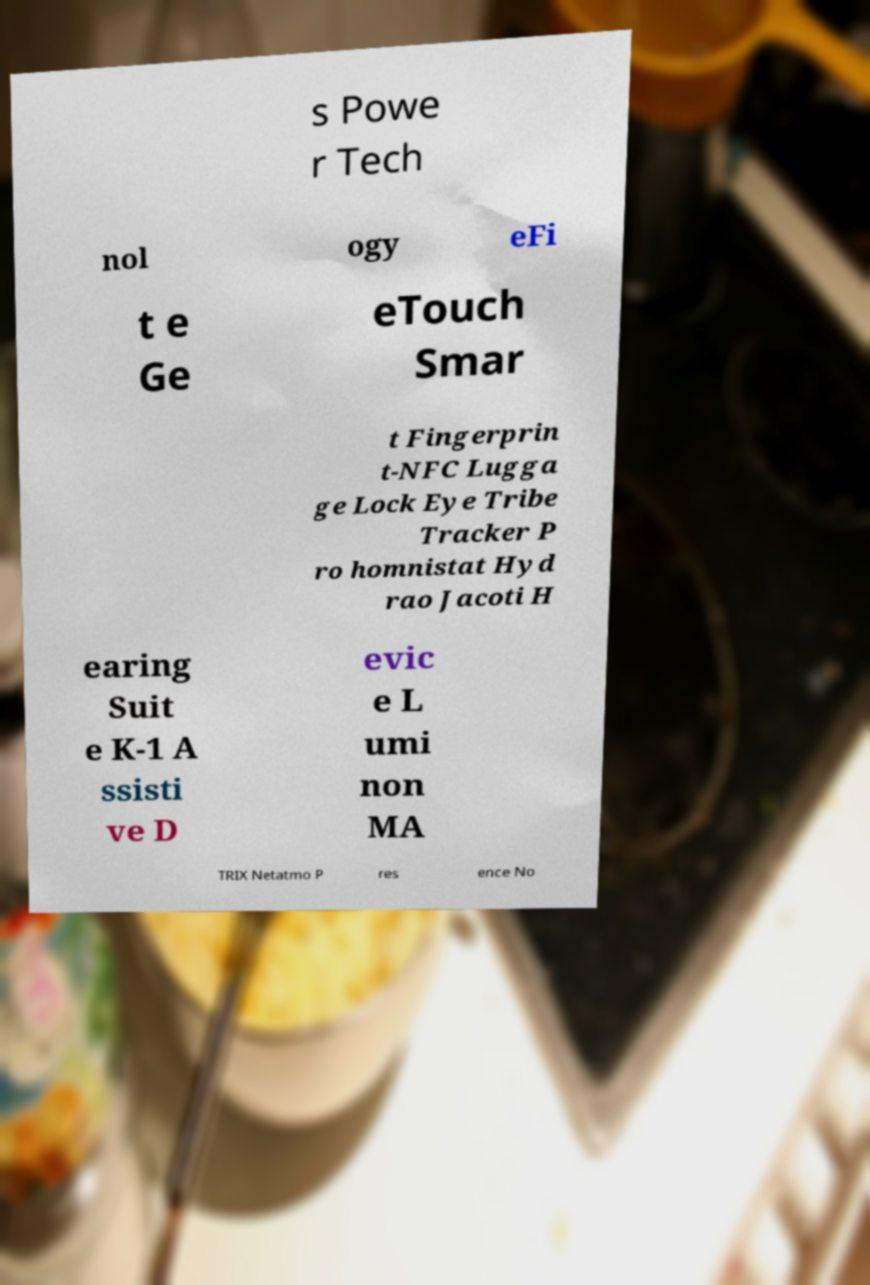What messages or text are displayed in this image? I need them in a readable, typed format. s Powe r Tech nol ogy eFi t e Ge eTouch Smar t Fingerprin t-NFC Lugga ge Lock Eye Tribe Tracker P ro homnistat Hyd rao Jacoti H earing Suit e K-1 A ssisti ve D evic e L umi non MA TRIX Netatmo P res ence No 